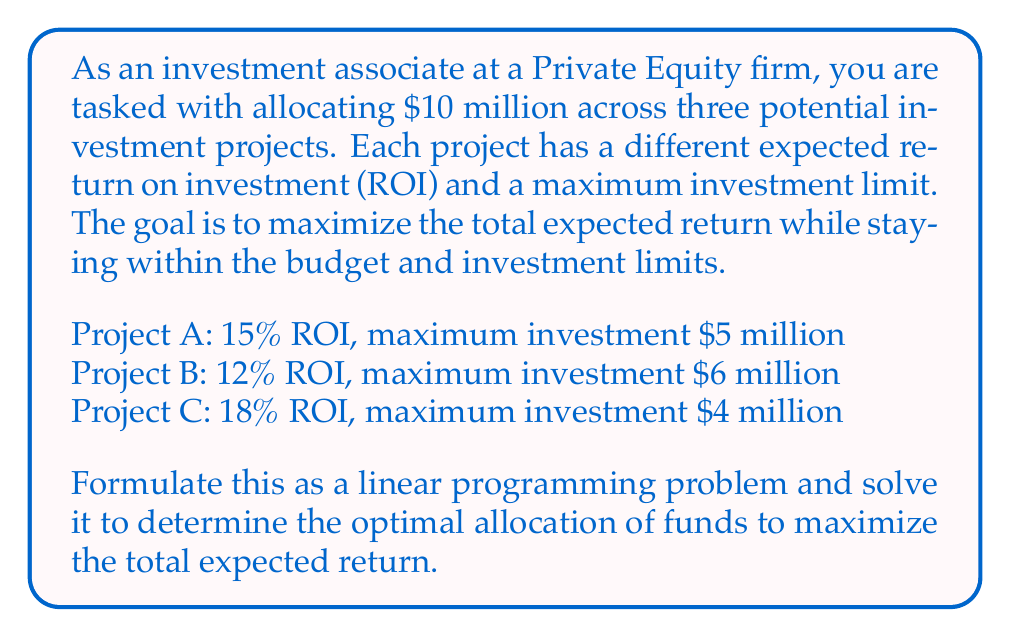Help me with this question. To solve this linear programming problem, we'll follow these steps:

1. Define variables:
Let $x_A$, $x_B$, and $x_C$ represent the amount invested in Projects A, B, and C, respectively.

2. Formulate the objective function:
Maximize: $Z = 0.15x_A + 0.12x_B + 0.18x_C$

3. Define constraints:
Budget constraint: $x_A + x_B + x_C \leq 10$ (in millions)
Project limits: $x_A \leq 5$, $x_B \leq 6$, $x_C \leq 4$
Non-negativity: $x_A, x_B, x_C \geq 0$

4. Solve using the simplex method or graphical method. In this case, we can use logical reasoning:

- Project C has the highest ROI (18%), so we should invest the maximum allowed ($4 million) in it.
- Project A has the second-highest ROI (15%), so we should invest the maximum allowed ($5 million) in it.
- We have $1 million left, which we'll invest in Project B.

5. Calculate the optimal allocation and total expected return:
$x_A = 5$, $x_B = 1$, $x_C = 4$

Total expected return:
$Z = 0.15(5) + 0.12(1) + 0.18(4) = 0.75 + 0.12 + 0.72 = 1.59$ million
Answer: The optimal allocation of funds is:
Project A: $5 million
Project B: $1 million
Project C: $4 million

The maximum total expected return is $1.59 million or 15.9% of the initial investment. 